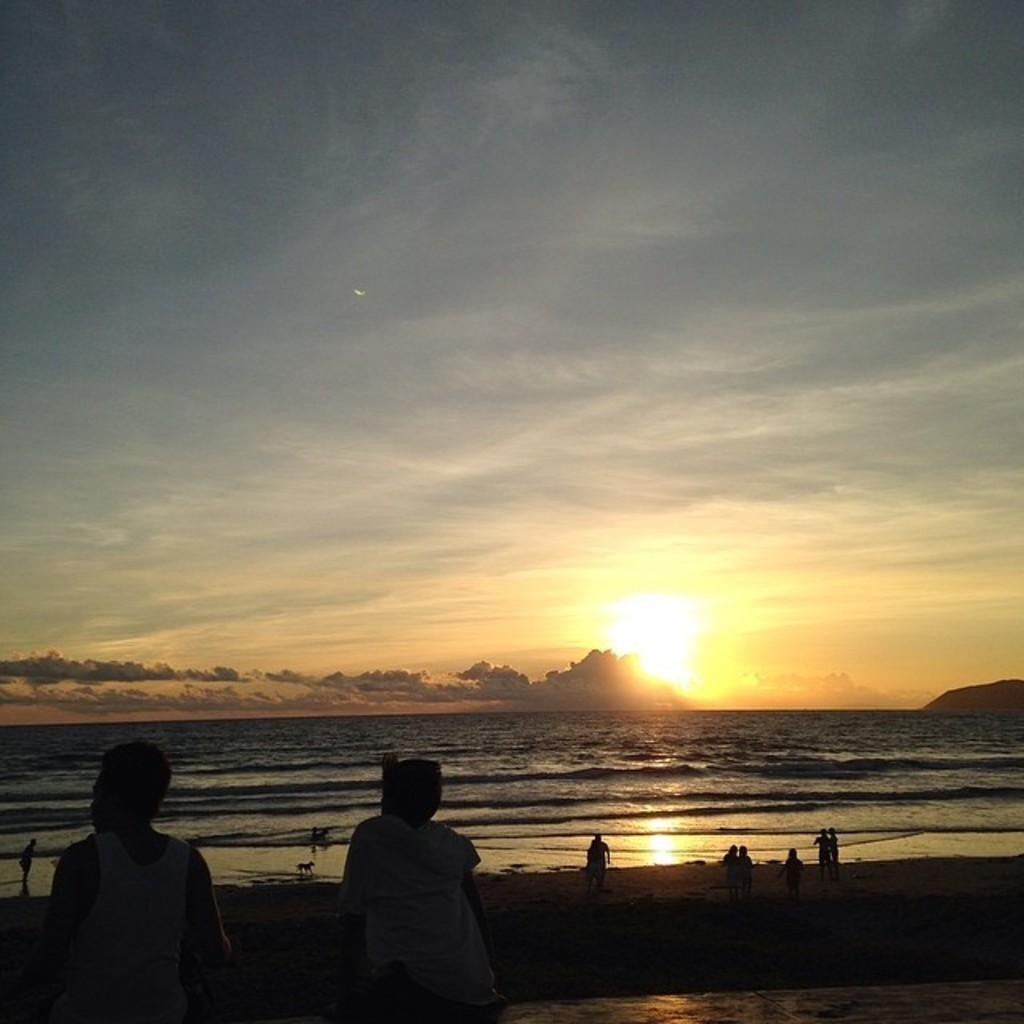What are the people in the image doing? Some people are standing, and some are seated in the image. Are there any animals present in the image? Yes, there is a dog in the image. What can be seen in the background of the image? There is water, trees, and a blue cloudy sky visible in the image. What type of light is being used to join the people together in the image? There is no light or joining activity present in the image; it simply shows people and a dog in a setting with water, trees, and a blue cloudy sky. 